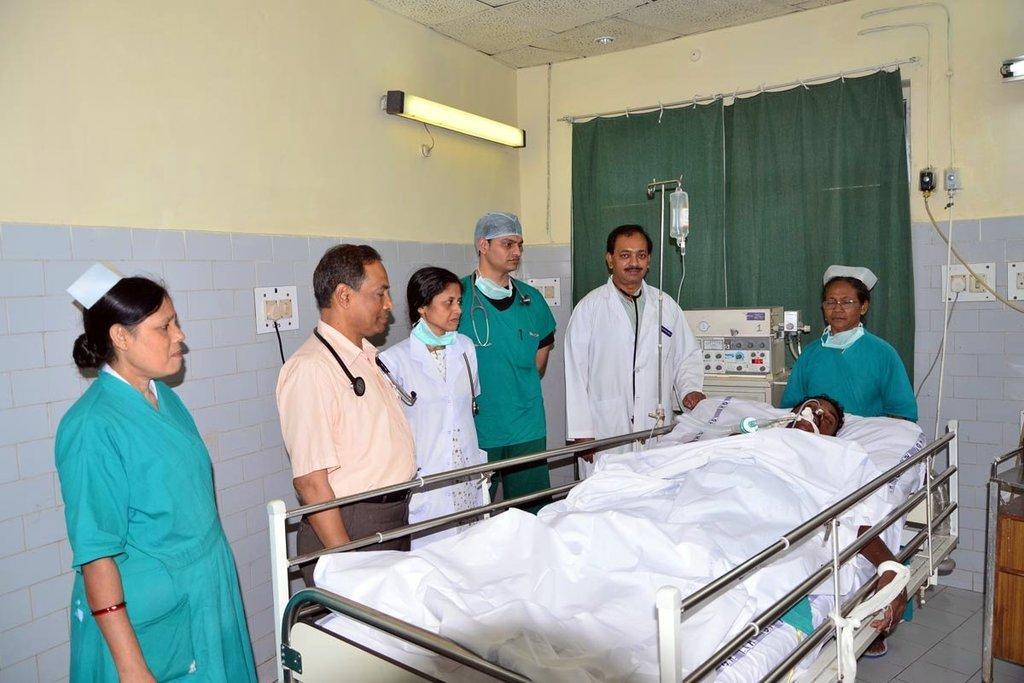Please provide a concise description of this image. In this image we can see a man lying on a bed. We can also see a group of people standing beside him, a machine, a bottle on a stand, curtains, a table, some switchboards and lights on a wall. 